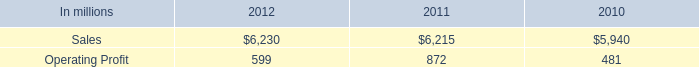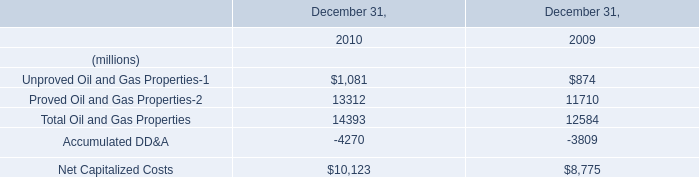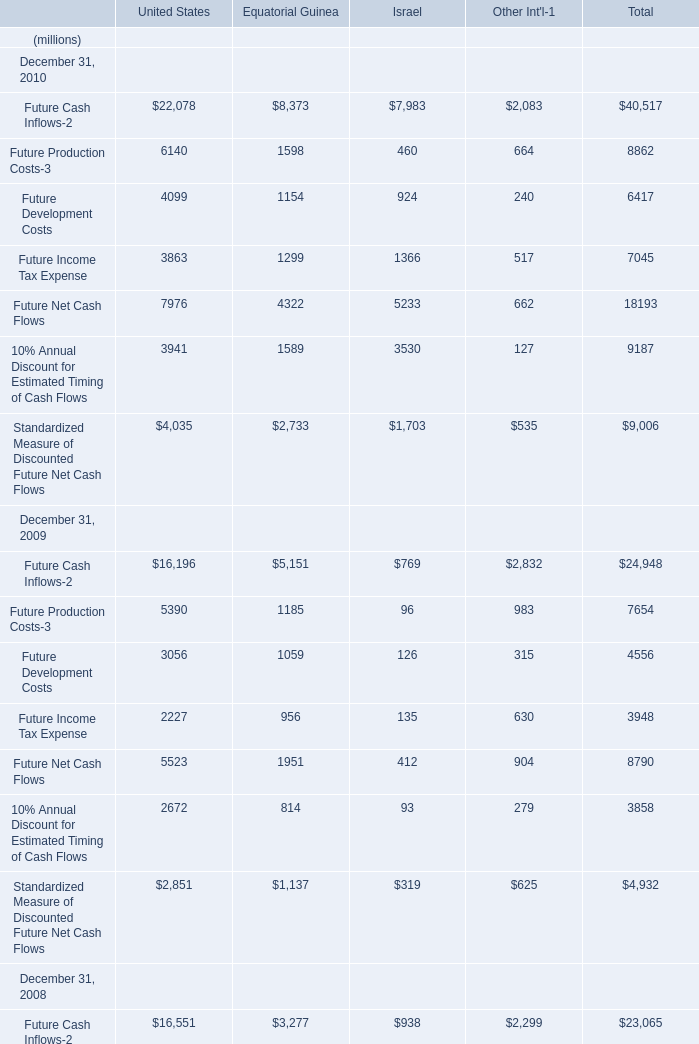what percentage of printing paper sales where north american printing papers sales in 2012? 
Computations: ((2.7 * 1000) / 6230)
Answer: 0.43339. 